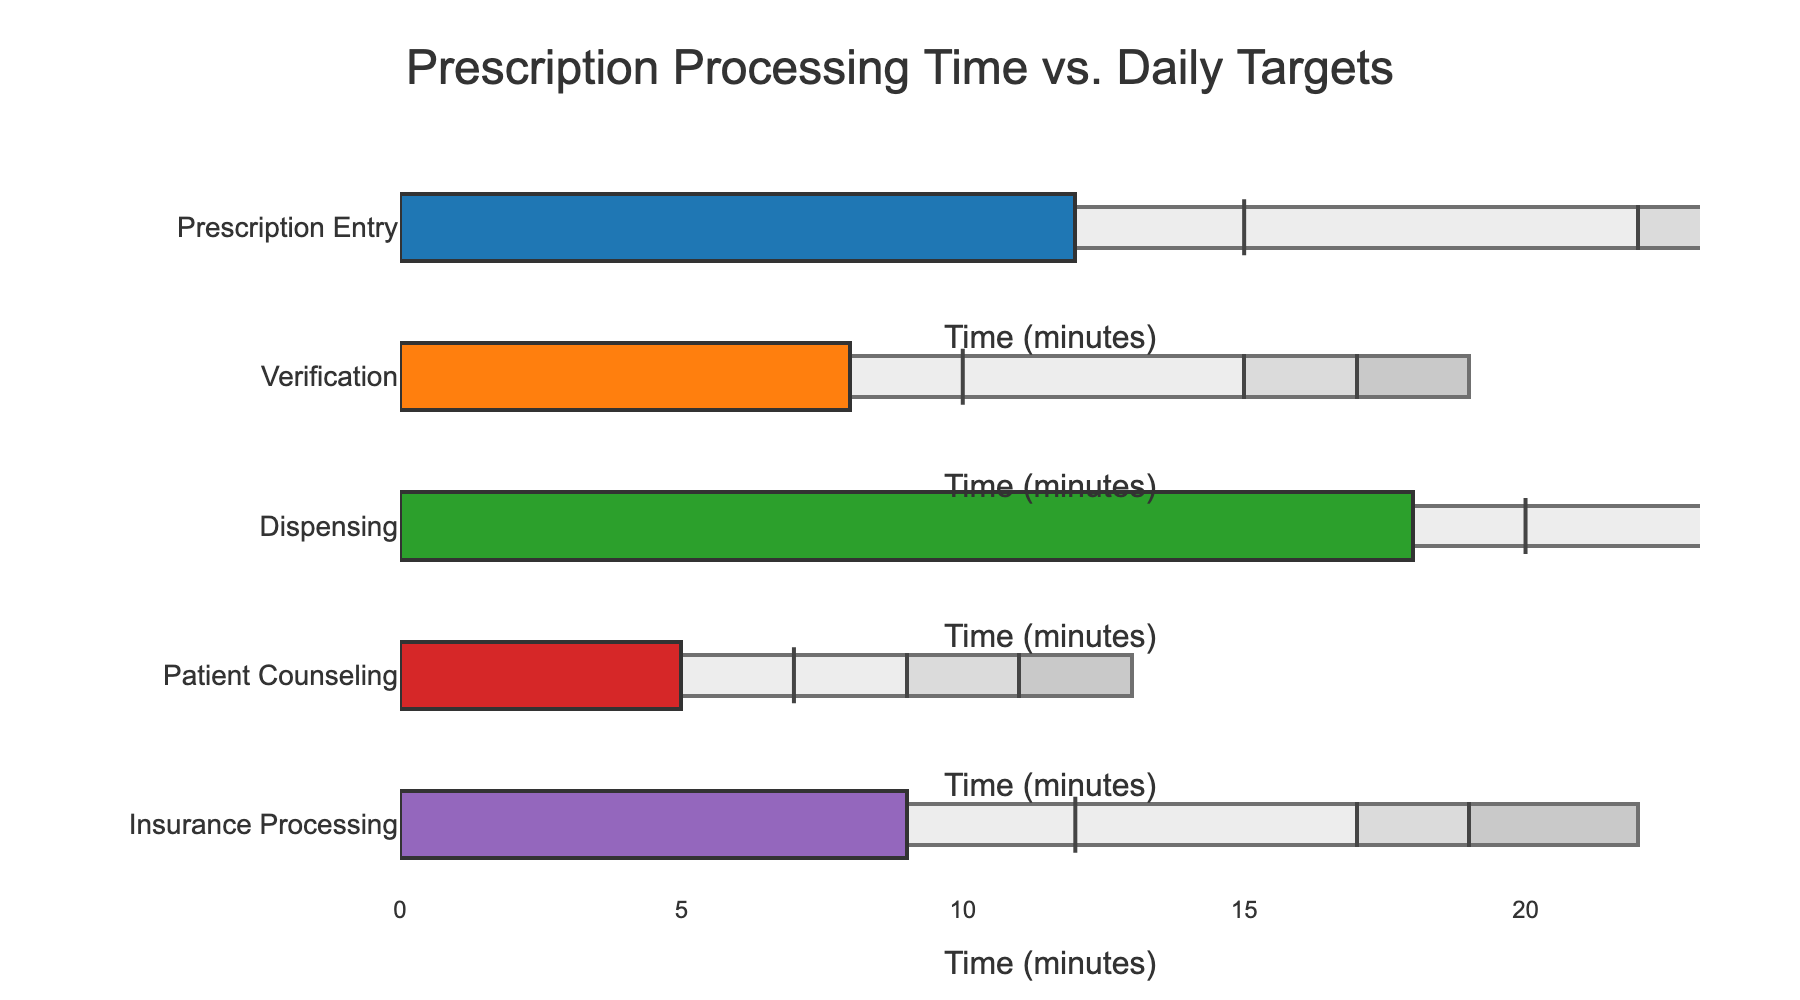Which processing category has the highest actual processing time? By looking at the bullet chart, the bar corresponding to "Dispensing" extends furthest along the horizontal axis, indicating it has the highest actual processing time.
Answer: Dispensing How much time separates the actual processing time from the target for "Verification"? The target processing time for Verification is 10 minutes, while the actual is 8 minutes. The difference is calculated by subtracting the actual time from the target time: 10 - 8 = 2.
Answer: 2 minutes Which categories meet or exceed their target processing times? Compare the actual processing time bars with the target markers for each category. Only "Patient Counseling" with 5 minutes falls well below its target of 7 minutes. Others do not meet their targets.
Answer: None What is the range of satisfactory processing times for "Insurance Processing"? The satisfactory range starts at 8 minutes (the poor threshold) and goes up to 10 minutes (the satisfactory threshold). Subtracting these values gives 10 - 8 = 2 minutes.
Answer: 2 minutes Which category has the lowest target processing time? By comparing the horizontal positions of the target markers, "Patient Counseling" has the lowest target time at 7 minutes.
Answer: Patient Counseling How far is "Prescription Entry" from entering the good processing time range? The good processing time for Prescription Entry starts at 16 minutes and its actual time is 12 minutes. The difference is 16 - 12 = 4 minutes.
Answer: 4 minutes How does the actual processing time for "Insurance Processing" compare to its poor processing range? The actual time for Insurance Processing is 9 minutes. The poor range ends at 10 minutes, indicating the actual time is within the satisfactory range.
Answer: Within satisfactory range What is the target marker's symbol on the bullet chart? The target markers on the bullet chart are represented by vertical black lines.
Answer: Vertical black lines 